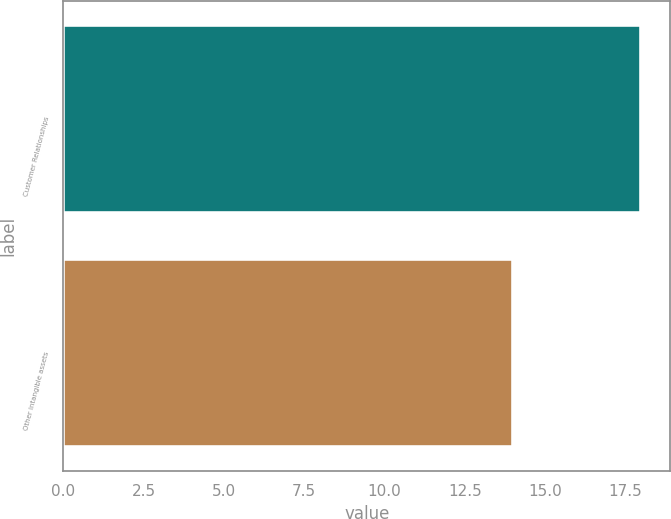Convert chart to OTSL. <chart><loc_0><loc_0><loc_500><loc_500><bar_chart><fcel>Customer Relationships<fcel>Other intangible assets<nl><fcel>18<fcel>14<nl></chart> 